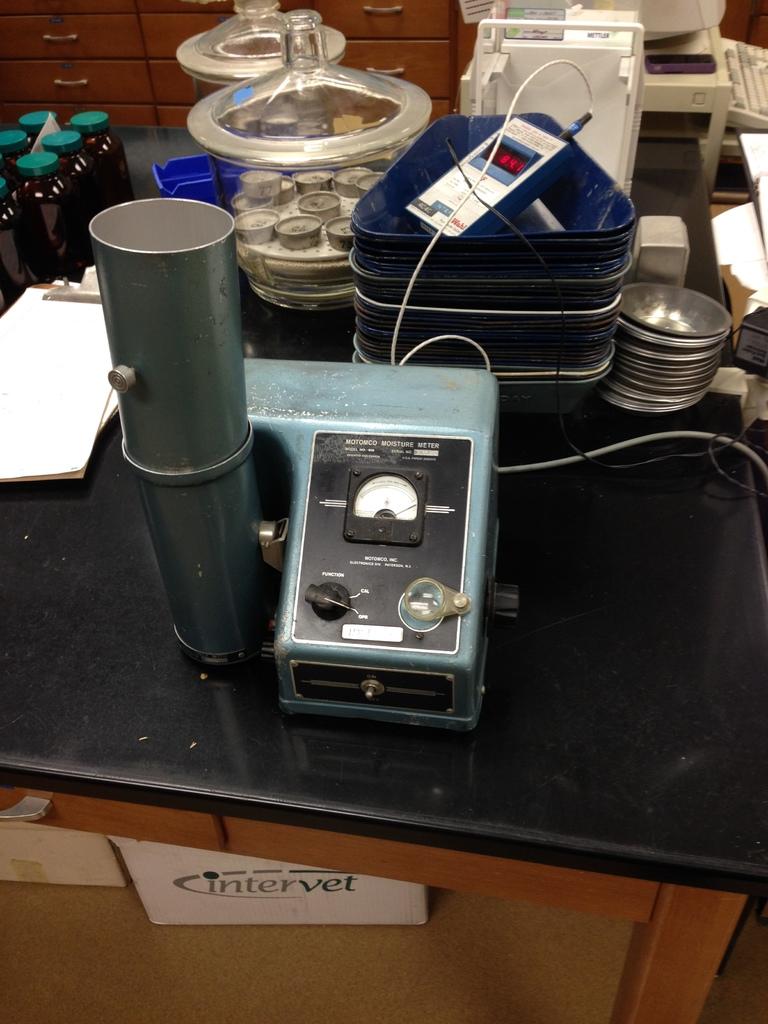What are they storing under the table?
Your answer should be very brief. Intervet. 